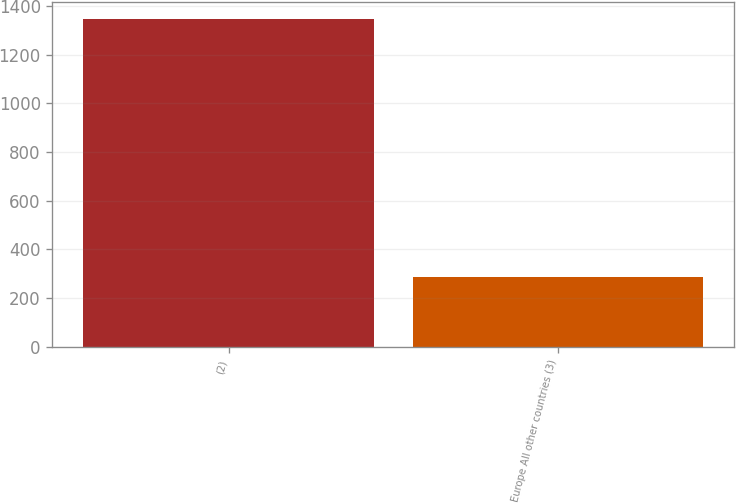Convert chart. <chart><loc_0><loc_0><loc_500><loc_500><bar_chart><fcel>(2)<fcel>Europe All other countries (3)<nl><fcel>1347.6<fcel>285.8<nl></chart> 